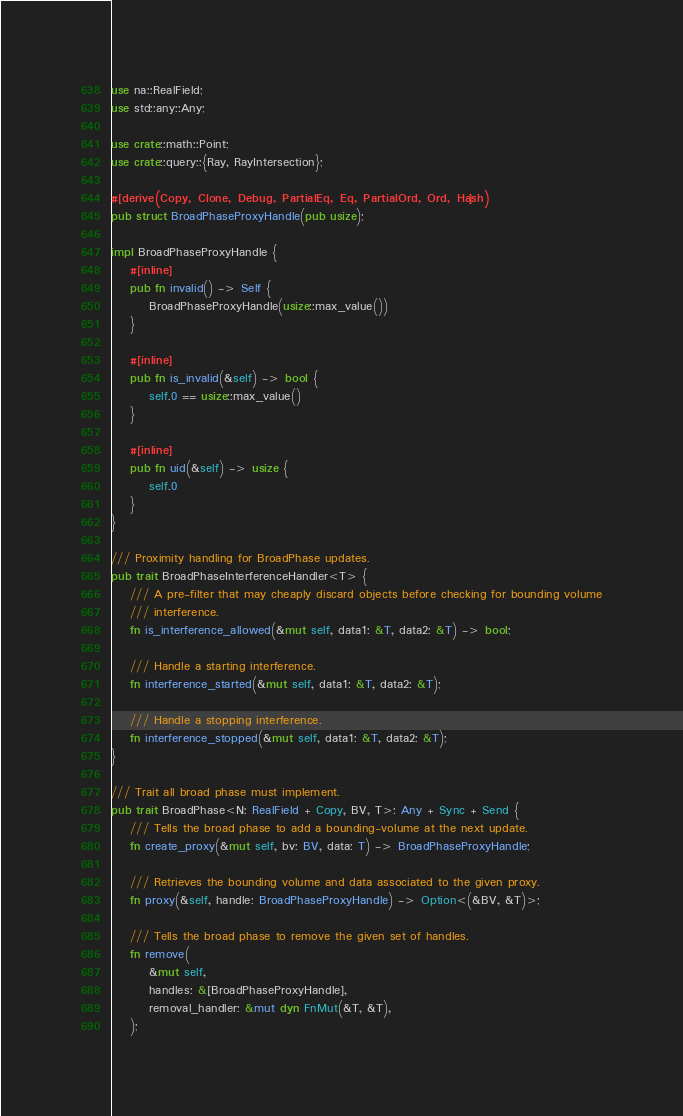Convert code to text. <code><loc_0><loc_0><loc_500><loc_500><_Rust_>use na::RealField;
use std::any::Any;

use crate::math::Point;
use crate::query::{Ray, RayIntersection};

#[derive(Copy, Clone, Debug, PartialEq, Eq, PartialOrd, Ord, Hash)]
pub struct BroadPhaseProxyHandle(pub usize);

impl BroadPhaseProxyHandle {
    #[inline]
    pub fn invalid() -> Self {
        BroadPhaseProxyHandle(usize::max_value())
    }

    #[inline]
    pub fn is_invalid(&self) -> bool {
        self.0 == usize::max_value()
    }

    #[inline]
    pub fn uid(&self) -> usize {
        self.0
    }
}

/// Proximity handling for BroadPhase updates.
pub trait BroadPhaseInterferenceHandler<T> {
    /// A pre-filter that may cheaply discard objects before checking for bounding volume
    /// interference.
    fn is_interference_allowed(&mut self, data1: &T, data2: &T) -> bool;

    /// Handle a starting interference.
    fn interference_started(&mut self, data1: &T, data2: &T);

    /// Handle a stopping interference.
    fn interference_stopped(&mut self, data1: &T, data2: &T);
}

/// Trait all broad phase must implement.
pub trait BroadPhase<N: RealField + Copy, BV, T>: Any + Sync + Send {
    /// Tells the broad phase to add a bounding-volume at the next update.
    fn create_proxy(&mut self, bv: BV, data: T) -> BroadPhaseProxyHandle;

    /// Retrieves the bounding volume and data associated to the given proxy.
    fn proxy(&self, handle: BroadPhaseProxyHandle) -> Option<(&BV, &T)>;

    /// Tells the broad phase to remove the given set of handles.
    fn remove(
        &mut self,
        handles: &[BroadPhaseProxyHandle],
        removal_handler: &mut dyn FnMut(&T, &T),
    );
</code> 